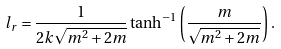Convert formula to latex. <formula><loc_0><loc_0><loc_500><loc_500>l _ { r } = \frac { 1 } { 2 k \sqrt { m ^ { 2 } + 2 m } } \tanh ^ { - 1 } \left ( \frac { m } { \sqrt { m ^ { 2 } + 2 m } } \right ) .</formula> 